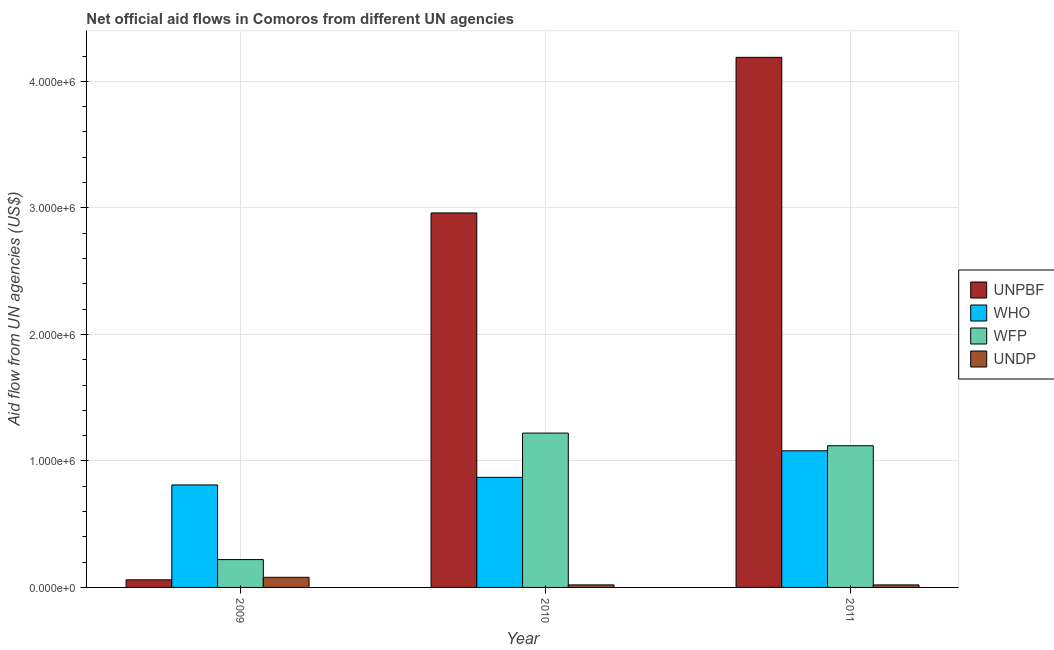How many groups of bars are there?
Keep it short and to the point. 3. Are the number of bars on each tick of the X-axis equal?
Provide a succinct answer. Yes. What is the label of the 1st group of bars from the left?
Offer a very short reply. 2009. In how many cases, is the number of bars for a given year not equal to the number of legend labels?
Provide a succinct answer. 0. What is the amount of aid given by undp in 2009?
Make the answer very short. 8.00e+04. Across all years, what is the maximum amount of aid given by who?
Make the answer very short. 1.08e+06. Across all years, what is the minimum amount of aid given by undp?
Provide a succinct answer. 2.00e+04. In which year was the amount of aid given by undp maximum?
Offer a very short reply. 2009. In which year was the amount of aid given by undp minimum?
Your response must be concise. 2010. What is the total amount of aid given by undp in the graph?
Offer a very short reply. 1.20e+05. What is the difference between the amount of aid given by undp in 2009 and that in 2010?
Your answer should be compact. 6.00e+04. What is the difference between the amount of aid given by who in 2010 and the amount of aid given by wfp in 2011?
Make the answer very short. -2.10e+05. What is the average amount of aid given by unpbf per year?
Provide a short and direct response. 2.40e+06. In how many years, is the amount of aid given by undp greater than 2000000 US$?
Give a very brief answer. 0. What is the ratio of the amount of aid given by wfp in 2009 to that in 2011?
Offer a terse response. 0.2. What is the difference between the highest and the second highest amount of aid given by who?
Provide a succinct answer. 2.10e+05. What is the difference between the highest and the lowest amount of aid given by undp?
Offer a very short reply. 6.00e+04. In how many years, is the amount of aid given by undp greater than the average amount of aid given by undp taken over all years?
Offer a very short reply. 1. Is the sum of the amount of aid given by wfp in 2009 and 2011 greater than the maximum amount of aid given by unpbf across all years?
Give a very brief answer. Yes. Is it the case that in every year, the sum of the amount of aid given by undp and amount of aid given by wfp is greater than the sum of amount of aid given by unpbf and amount of aid given by who?
Ensure brevity in your answer.  No. What does the 3rd bar from the left in 2010 represents?
Make the answer very short. WFP. What does the 3rd bar from the right in 2011 represents?
Your answer should be very brief. WHO. Is it the case that in every year, the sum of the amount of aid given by unpbf and amount of aid given by who is greater than the amount of aid given by wfp?
Give a very brief answer. Yes. How many years are there in the graph?
Your answer should be compact. 3. Does the graph contain any zero values?
Give a very brief answer. No. Does the graph contain grids?
Provide a short and direct response. Yes. Where does the legend appear in the graph?
Your answer should be very brief. Center right. How many legend labels are there?
Ensure brevity in your answer.  4. What is the title of the graph?
Keep it short and to the point. Net official aid flows in Comoros from different UN agencies. What is the label or title of the X-axis?
Offer a very short reply. Year. What is the label or title of the Y-axis?
Provide a succinct answer. Aid flow from UN agencies (US$). What is the Aid flow from UN agencies (US$) in UNPBF in 2009?
Provide a short and direct response. 6.00e+04. What is the Aid flow from UN agencies (US$) in WHO in 2009?
Provide a succinct answer. 8.10e+05. What is the Aid flow from UN agencies (US$) in UNDP in 2009?
Give a very brief answer. 8.00e+04. What is the Aid flow from UN agencies (US$) in UNPBF in 2010?
Keep it short and to the point. 2.96e+06. What is the Aid flow from UN agencies (US$) in WHO in 2010?
Your response must be concise. 8.70e+05. What is the Aid flow from UN agencies (US$) in WFP in 2010?
Your answer should be very brief. 1.22e+06. What is the Aid flow from UN agencies (US$) of UNPBF in 2011?
Offer a terse response. 4.19e+06. What is the Aid flow from UN agencies (US$) in WHO in 2011?
Your response must be concise. 1.08e+06. What is the Aid flow from UN agencies (US$) in WFP in 2011?
Provide a short and direct response. 1.12e+06. Across all years, what is the maximum Aid flow from UN agencies (US$) in UNPBF?
Offer a terse response. 4.19e+06. Across all years, what is the maximum Aid flow from UN agencies (US$) of WHO?
Offer a very short reply. 1.08e+06. Across all years, what is the maximum Aid flow from UN agencies (US$) in WFP?
Ensure brevity in your answer.  1.22e+06. Across all years, what is the minimum Aid flow from UN agencies (US$) in UNPBF?
Make the answer very short. 6.00e+04. Across all years, what is the minimum Aid flow from UN agencies (US$) of WHO?
Your response must be concise. 8.10e+05. Across all years, what is the minimum Aid flow from UN agencies (US$) in WFP?
Provide a succinct answer. 2.20e+05. What is the total Aid flow from UN agencies (US$) in UNPBF in the graph?
Offer a terse response. 7.21e+06. What is the total Aid flow from UN agencies (US$) in WHO in the graph?
Keep it short and to the point. 2.76e+06. What is the total Aid flow from UN agencies (US$) of WFP in the graph?
Make the answer very short. 2.56e+06. What is the total Aid flow from UN agencies (US$) in UNDP in the graph?
Provide a succinct answer. 1.20e+05. What is the difference between the Aid flow from UN agencies (US$) of UNPBF in 2009 and that in 2010?
Your answer should be compact. -2.90e+06. What is the difference between the Aid flow from UN agencies (US$) of WHO in 2009 and that in 2010?
Offer a terse response. -6.00e+04. What is the difference between the Aid flow from UN agencies (US$) in WFP in 2009 and that in 2010?
Your answer should be compact. -1.00e+06. What is the difference between the Aid flow from UN agencies (US$) of UNDP in 2009 and that in 2010?
Keep it short and to the point. 6.00e+04. What is the difference between the Aid flow from UN agencies (US$) in UNPBF in 2009 and that in 2011?
Offer a very short reply. -4.13e+06. What is the difference between the Aid flow from UN agencies (US$) of WFP in 2009 and that in 2011?
Make the answer very short. -9.00e+05. What is the difference between the Aid flow from UN agencies (US$) of UNDP in 2009 and that in 2011?
Keep it short and to the point. 6.00e+04. What is the difference between the Aid flow from UN agencies (US$) of UNPBF in 2010 and that in 2011?
Make the answer very short. -1.23e+06. What is the difference between the Aid flow from UN agencies (US$) of WHO in 2010 and that in 2011?
Keep it short and to the point. -2.10e+05. What is the difference between the Aid flow from UN agencies (US$) in UNPBF in 2009 and the Aid flow from UN agencies (US$) in WHO in 2010?
Provide a short and direct response. -8.10e+05. What is the difference between the Aid flow from UN agencies (US$) of UNPBF in 2009 and the Aid flow from UN agencies (US$) of WFP in 2010?
Keep it short and to the point. -1.16e+06. What is the difference between the Aid flow from UN agencies (US$) of UNPBF in 2009 and the Aid flow from UN agencies (US$) of UNDP in 2010?
Your answer should be very brief. 4.00e+04. What is the difference between the Aid flow from UN agencies (US$) in WHO in 2009 and the Aid flow from UN agencies (US$) in WFP in 2010?
Provide a succinct answer. -4.10e+05. What is the difference between the Aid flow from UN agencies (US$) of WHO in 2009 and the Aid flow from UN agencies (US$) of UNDP in 2010?
Make the answer very short. 7.90e+05. What is the difference between the Aid flow from UN agencies (US$) in WFP in 2009 and the Aid flow from UN agencies (US$) in UNDP in 2010?
Keep it short and to the point. 2.00e+05. What is the difference between the Aid flow from UN agencies (US$) of UNPBF in 2009 and the Aid flow from UN agencies (US$) of WHO in 2011?
Offer a very short reply. -1.02e+06. What is the difference between the Aid flow from UN agencies (US$) of UNPBF in 2009 and the Aid flow from UN agencies (US$) of WFP in 2011?
Provide a short and direct response. -1.06e+06. What is the difference between the Aid flow from UN agencies (US$) in WHO in 2009 and the Aid flow from UN agencies (US$) in WFP in 2011?
Give a very brief answer. -3.10e+05. What is the difference between the Aid flow from UN agencies (US$) of WHO in 2009 and the Aid flow from UN agencies (US$) of UNDP in 2011?
Provide a succinct answer. 7.90e+05. What is the difference between the Aid flow from UN agencies (US$) of UNPBF in 2010 and the Aid flow from UN agencies (US$) of WHO in 2011?
Keep it short and to the point. 1.88e+06. What is the difference between the Aid flow from UN agencies (US$) in UNPBF in 2010 and the Aid flow from UN agencies (US$) in WFP in 2011?
Your answer should be compact. 1.84e+06. What is the difference between the Aid flow from UN agencies (US$) of UNPBF in 2010 and the Aid flow from UN agencies (US$) of UNDP in 2011?
Offer a very short reply. 2.94e+06. What is the difference between the Aid flow from UN agencies (US$) in WHO in 2010 and the Aid flow from UN agencies (US$) in WFP in 2011?
Offer a very short reply. -2.50e+05. What is the difference between the Aid flow from UN agencies (US$) in WHO in 2010 and the Aid flow from UN agencies (US$) in UNDP in 2011?
Your answer should be compact. 8.50e+05. What is the difference between the Aid flow from UN agencies (US$) of WFP in 2010 and the Aid flow from UN agencies (US$) of UNDP in 2011?
Make the answer very short. 1.20e+06. What is the average Aid flow from UN agencies (US$) in UNPBF per year?
Offer a terse response. 2.40e+06. What is the average Aid flow from UN agencies (US$) of WHO per year?
Offer a terse response. 9.20e+05. What is the average Aid flow from UN agencies (US$) of WFP per year?
Offer a terse response. 8.53e+05. In the year 2009, what is the difference between the Aid flow from UN agencies (US$) in UNPBF and Aid flow from UN agencies (US$) in WHO?
Make the answer very short. -7.50e+05. In the year 2009, what is the difference between the Aid flow from UN agencies (US$) in WHO and Aid flow from UN agencies (US$) in WFP?
Your answer should be compact. 5.90e+05. In the year 2009, what is the difference between the Aid flow from UN agencies (US$) in WHO and Aid flow from UN agencies (US$) in UNDP?
Your answer should be very brief. 7.30e+05. In the year 2009, what is the difference between the Aid flow from UN agencies (US$) of WFP and Aid flow from UN agencies (US$) of UNDP?
Offer a terse response. 1.40e+05. In the year 2010, what is the difference between the Aid flow from UN agencies (US$) in UNPBF and Aid flow from UN agencies (US$) in WHO?
Offer a very short reply. 2.09e+06. In the year 2010, what is the difference between the Aid flow from UN agencies (US$) of UNPBF and Aid flow from UN agencies (US$) of WFP?
Keep it short and to the point. 1.74e+06. In the year 2010, what is the difference between the Aid flow from UN agencies (US$) of UNPBF and Aid flow from UN agencies (US$) of UNDP?
Your response must be concise. 2.94e+06. In the year 2010, what is the difference between the Aid flow from UN agencies (US$) of WHO and Aid flow from UN agencies (US$) of WFP?
Provide a short and direct response. -3.50e+05. In the year 2010, what is the difference between the Aid flow from UN agencies (US$) of WHO and Aid flow from UN agencies (US$) of UNDP?
Make the answer very short. 8.50e+05. In the year 2010, what is the difference between the Aid flow from UN agencies (US$) of WFP and Aid flow from UN agencies (US$) of UNDP?
Provide a short and direct response. 1.20e+06. In the year 2011, what is the difference between the Aid flow from UN agencies (US$) of UNPBF and Aid flow from UN agencies (US$) of WHO?
Offer a terse response. 3.11e+06. In the year 2011, what is the difference between the Aid flow from UN agencies (US$) in UNPBF and Aid flow from UN agencies (US$) in WFP?
Offer a terse response. 3.07e+06. In the year 2011, what is the difference between the Aid flow from UN agencies (US$) of UNPBF and Aid flow from UN agencies (US$) of UNDP?
Keep it short and to the point. 4.17e+06. In the year 2011, what is the difference between the Aid flow from UN agencies (US$) in WHO and Aid flow from UN agencies (US$) in WFP?
Your answer should be compact. -4.00e+04. In the year 2011, what is the difference between the Aid flow from UN agencies (US$) in WHO and Aid flow from UN agencies (US$) in UNDP?
Keep it short and to the point. 1.06e+06. In the year 2011, what is the difference between the Aid flow from UN agencies (US$) in WFP and Aid flow from UN agencies (US$) in UNDP?
Offer a very short reply. 1.10e+06. What is the ratio of the Aid flow from UN agencies (US$) in UNPBF in 2009 to that in 2010?
Provide a short and direct response. 0.02. What is the ratio of the Aid flow from UN agencies (US$) in WHO in 2009 to that in 2010?
Keep it short and to the point. 0.93. What is the ratio of the Aid flow from UN agencies (US$) in WFP in 2009 to that in 2010?
Your answer should be very brief. 0.18. What is the ratio of the Aid flow from UN agencies (US$) in UNPBF in 2009 to that in 2011?
Offer a terse response. 0.01. What is the ratio of the Aid flow from UN agencies (US$) in WHO in 2009 to that in 2011?
Your answer should be compact. 0.75. What is the ratio of the Aid flow from UN agencies (US$) in WFP in 2009 to that in 2011?
Your answer should be compact. 0.2. What is the ratio of the Aid flow from UN agencies (US$) of UNPBF in 2010 to that in 2011?
Keep it short and to the point. 0.71. What is the ratio of the Aid flow from UN agencies (US$) in WHO in 2010 to that in 2011?
Keep it short and to the point. 0.81. What is the ratio of the Aid flow from UN agencies (US$) in WFP in 2010 to that in 2011?
Your answer should be very brief. 1.09. What is the difference between the highest and the second highest Aid flow from UN agencies (US$) in UNPBF?
Your answer should be compact. 1.23e+06. What is the difference between the highest and the second highest Aid flow from UN agencies (US$) in WHO?
Make the answer very short. 2.10e+05. What is the difference between the highest and the second highest Aid flow from UN agencies (US$) of UNDP?
Your response must be concise. 6.00e+04. What is the difference between the highest and the lowest Aid flow from UN agencies (US$) in UNPBF?
Your answer should be very brief. 4.13e+06. What is the difference between the highest and the lowest Aid flow from UN agencies (US$) in WHO?
Ensure brevity in your answer.  2.70e+05. What is the difference between the highest and the lowest Aid flow from UN agencies (US$) in WFP?
Provide a succinct answer. 1.00e+06. What is the difference between the highest and the lowest Aid flow from UN agencies (US$) of UNDP?
Ensure brevity in your answer.  6.00e+04. 